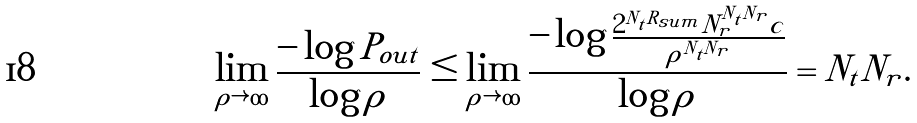Convert formula to latex. <formula><loc_0><loc_0><loc_500><loc_500>\lim _ { \rho \rightarrow \infty } \frac { - \log P _ { o u t } } { \log \rho } \leq \lim _ { \rho \rightarrow \infty } \frac { - \log \frac { 2 ^ { N _ { t } R _ { s u m } } N _ { r } ^ { N _ { t } N _ { r } } c } { \rho ^ { N _ { t } N _ { r } } } } { \log \rho } = N _ { t } N _ { r } .</formula> 